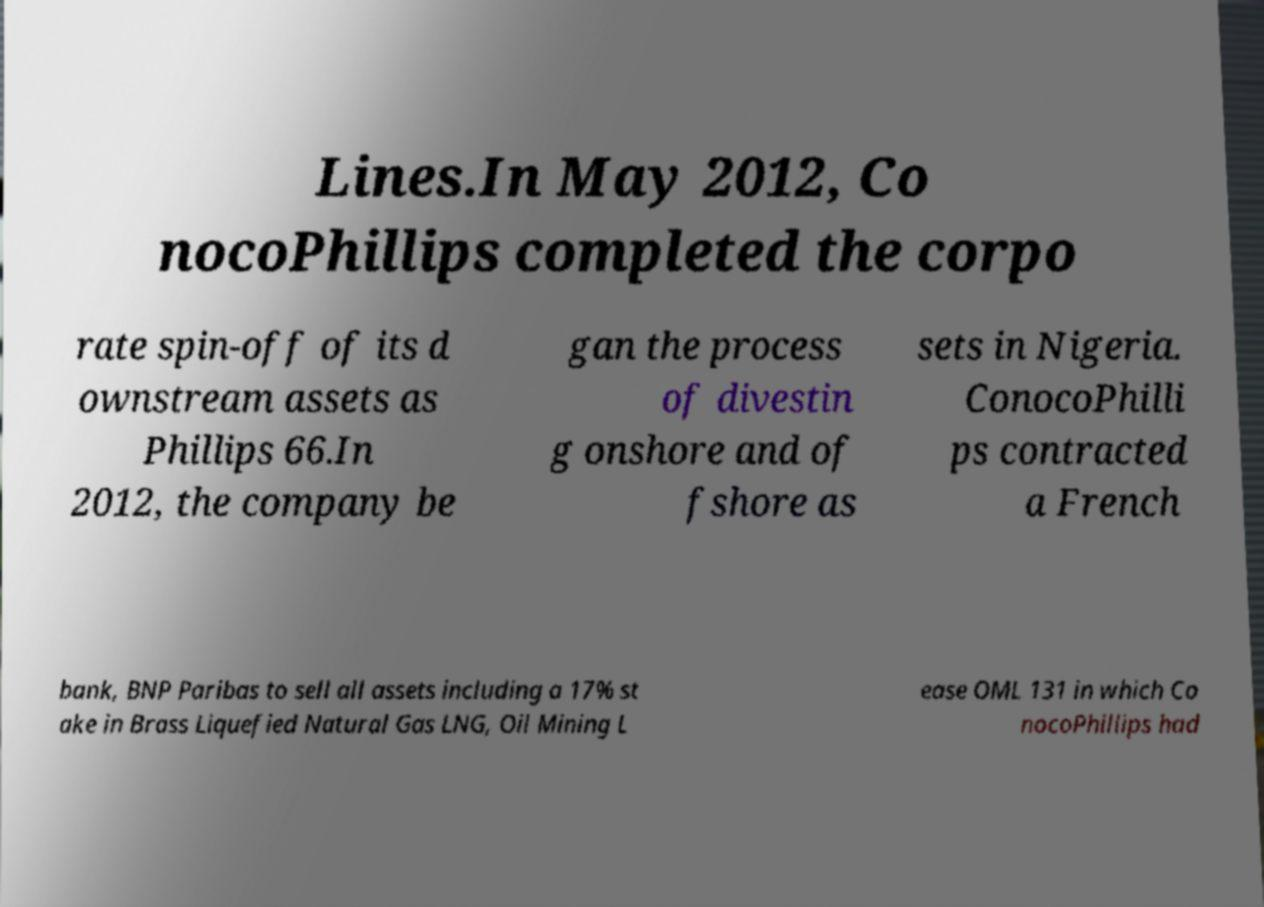Can you read and provide the text displayed in the image?This photo seems to have some interesting text. Can you extract and type it out for me? Lines.In May 2012, Co nocoPhillips completed the corpo rate spin-off of its d ownstream assets as Phillips 66.In 2012, the company be gan the process of divestin g onshore and of fshore as sets in Nigeria. ConocoPhilli ps contracted a French bank, BNP Paribas to sell all assets including a 17% st ake in Brass Liquefied Natural Gas LNG, Oil Mining L ease OML 131 in which Co nocoPhillips had 